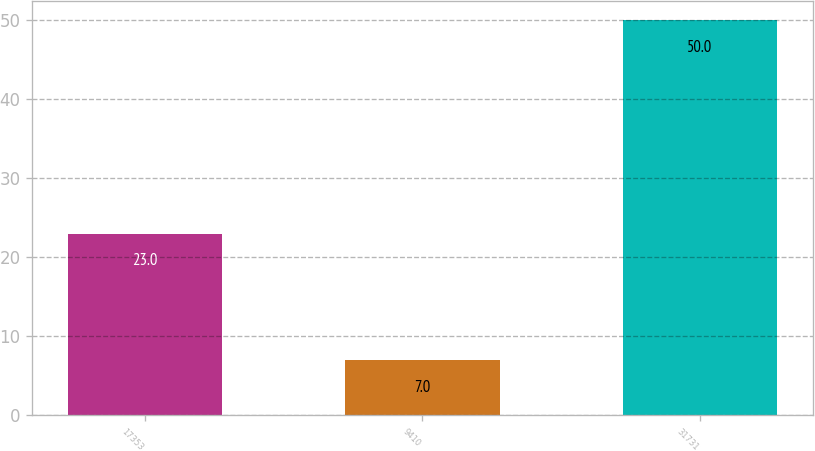<chart> <loc_0><loc_0><loc_500><loc_500><bar_chart><fcel>17353<fcel>9410<fcel>31731<nl><fcel>23<fcel>7<fcel>50<nl></chart> 